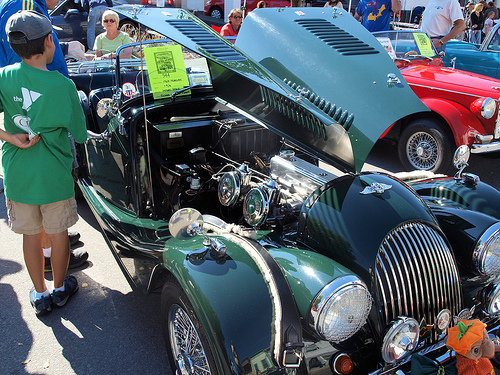<image>
Can you confirm if the person is in the car? No. The person is not contained within the car. These objects have a different spatial relationship. Where is the tacky shirt in relation to the pumpkin head? Is it above the pumpkin head? Yes. The tacky shirt is positioned above the pumpkin head in the vertical space, higher up in the scene. 